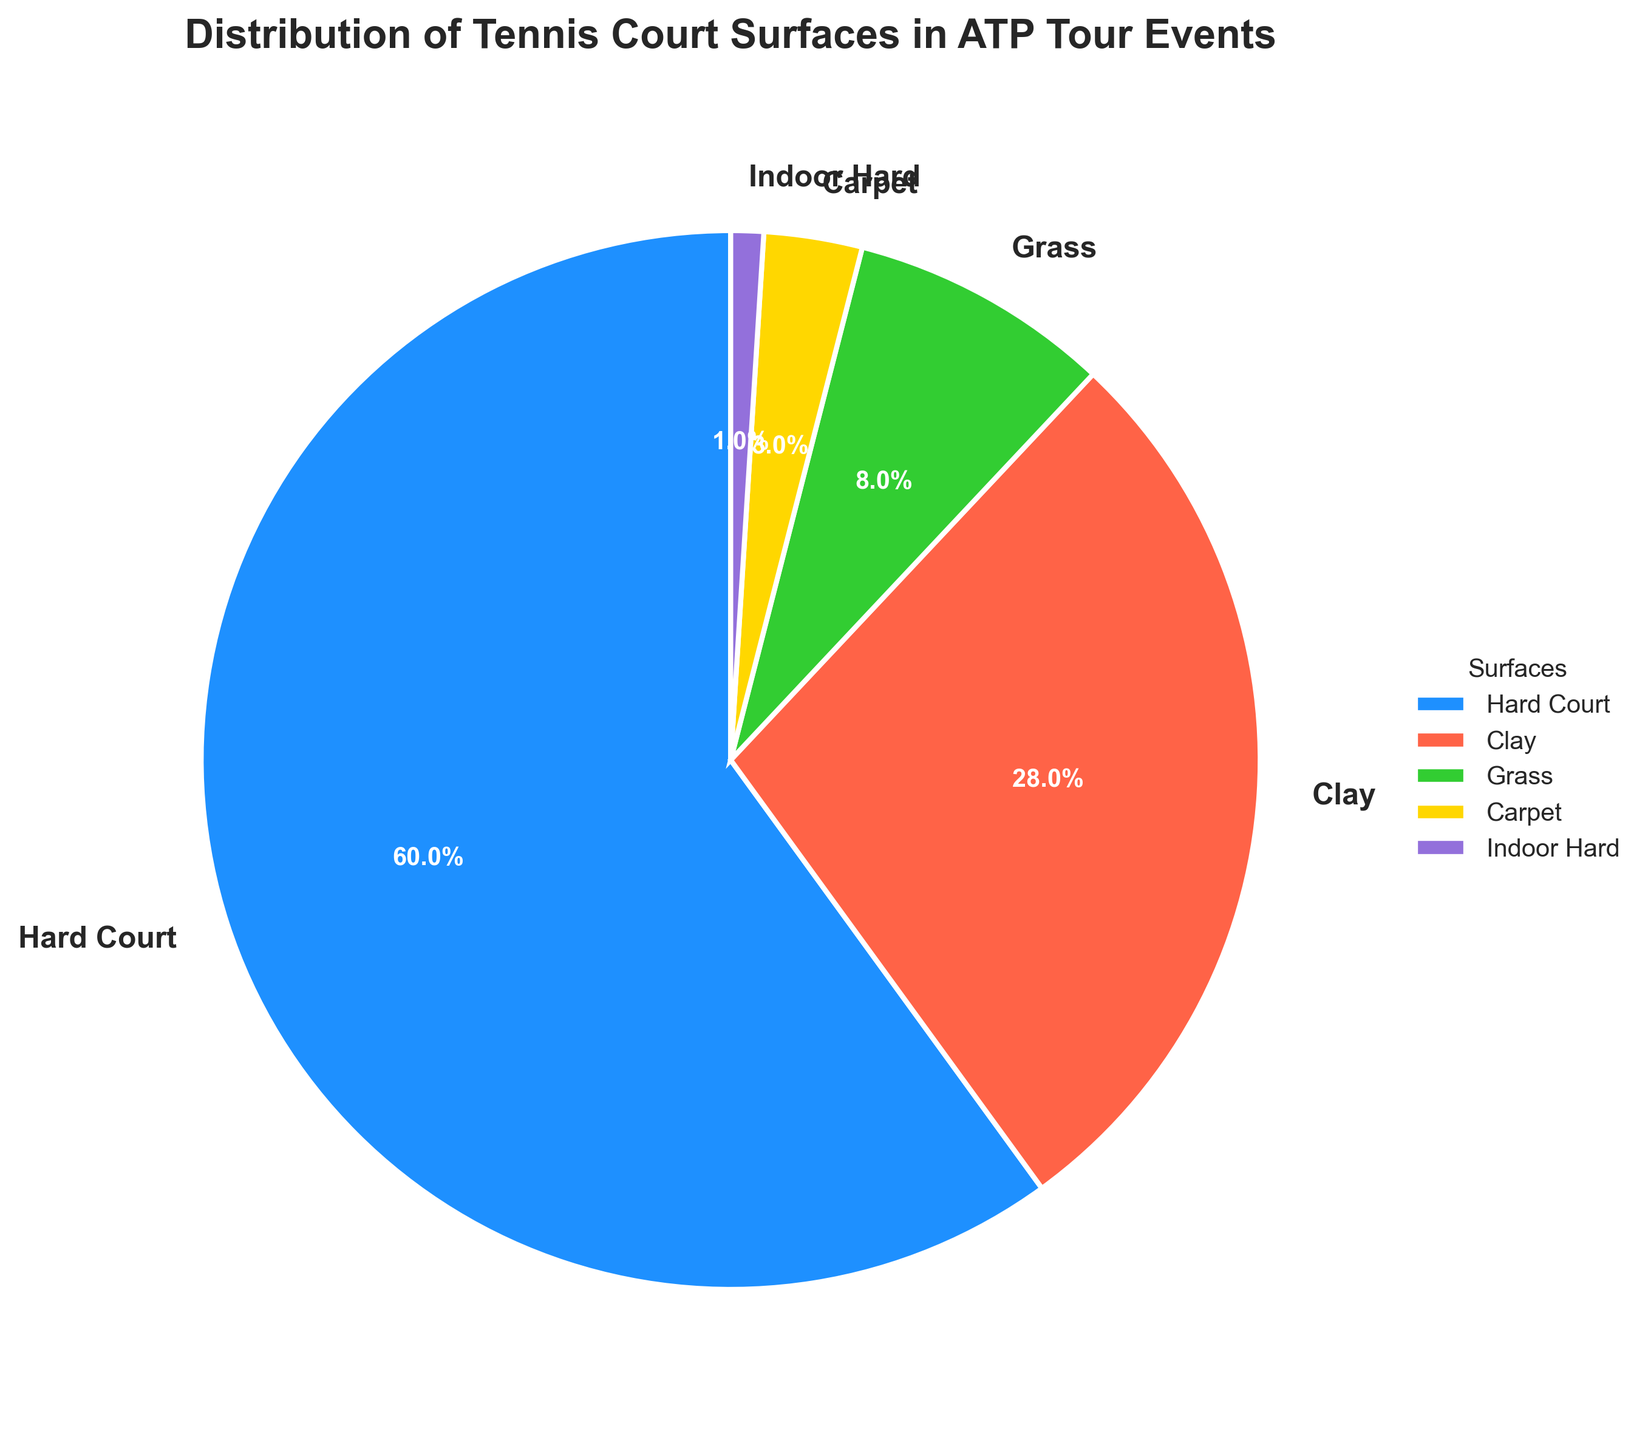What percentage of ATP Tour events are played on grass courts? Grass court percentage is labeled directly in the pie chart.
Answer: 8% How does the percentage of clay court events compare to hard court events? By looking at the chart, clay court has 28% and hard court has 60%.
Answer: Hard court events are more frequent than clay court events Which two surfaces combined make up less than 5% of the total ATP Tour events? By examining the pie chart, indoor hard is 1% and carpet is 3%, together less than 5%.
Answer: Carpet and Indoor Hard What is the combined percentage of events played on surfaces other than hard courts? Sum the percentages of clay (28%), grass (8%), carpet (3%), and indoor hard (1%).
Answer: 40% Is the percentage of hard court events greater than the combined percentage of all other surfaces? Hard court is 60%, and combined percentage of other surfaces is 40%, which is less.
Answer: Yes What surface has the smallest percentage of ATP Tour events? The pie chart shows indoor hard courts with the smallest percentage at 1%.
Answer: Indoor Hard How many times higher is the percentage of hard court events than carpet court events? Hard is 60% and carpet is 3%; to find the ratio, divide 60 by 3.
Answer: 20 times Which surface is depicted in gold color and what is its percentage? The pie piece in gold color represents carpet courts, with a percentage of 3%.
Answer: Carpet, 3% What is the difference in percentage between grass and carpet court events? Grass is 8% and carpet is 3%; the difference is obtained by subtracting 3 from 8.
Answer: 5% Between clay and grass courts, which one has a higher percentage and what is the difference? Clay courts have 28% and grass courts have 8%; subtract 8 from 28 to get the difference.
Answer: Clay, 20% 